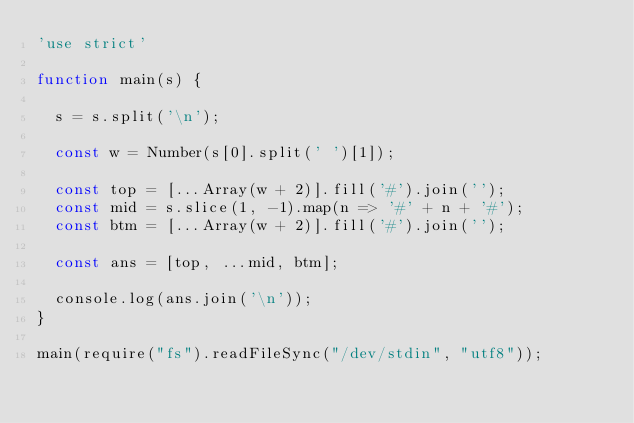<code> <loc_0><loc_0><loc_500><loc_500><_JavaScript_>'use strict'

function main(s) {

  s = s.split('\n');

  const w = Number(s[0].split(' ')[1]);

  const top = [...Array(w + 2)].fill('#').join('');
  const mid = s.slice(1, -1).map(n => '#' + n + '#');
  const btm = [...Array(w + 2)].fill('#').join('');

  const ans = [top, ...mid, btm];

  console.log(ans.join('\n'));
}

main(require("fs").readFileSync("/dev/stdin", "utf8"));
</code> 